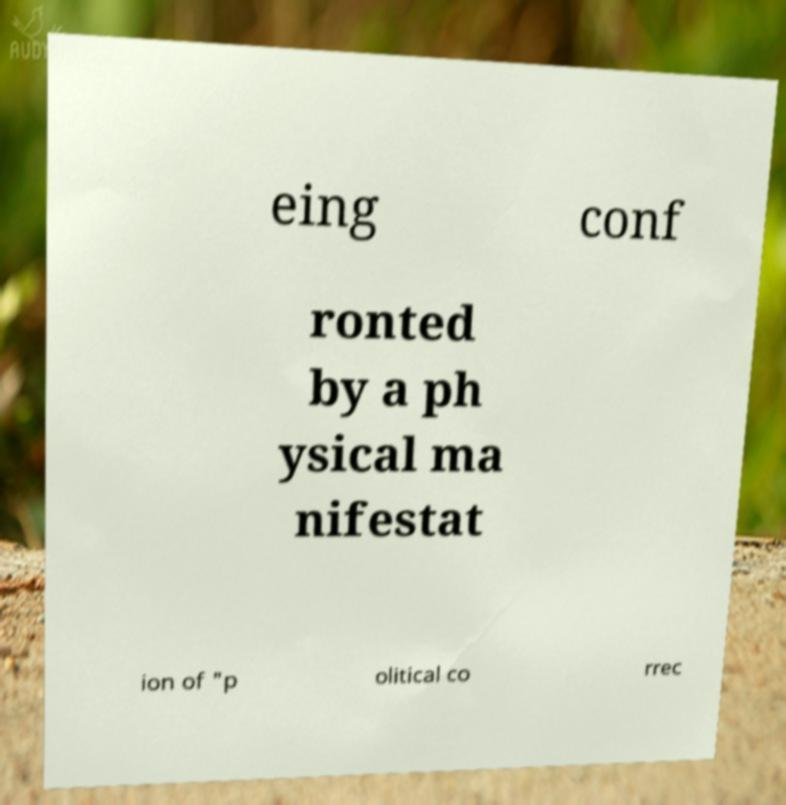Could you extract and type out the text from this image? eing conf ronted by a ph ysical ma nifestat ion of "p olitical co rrec 